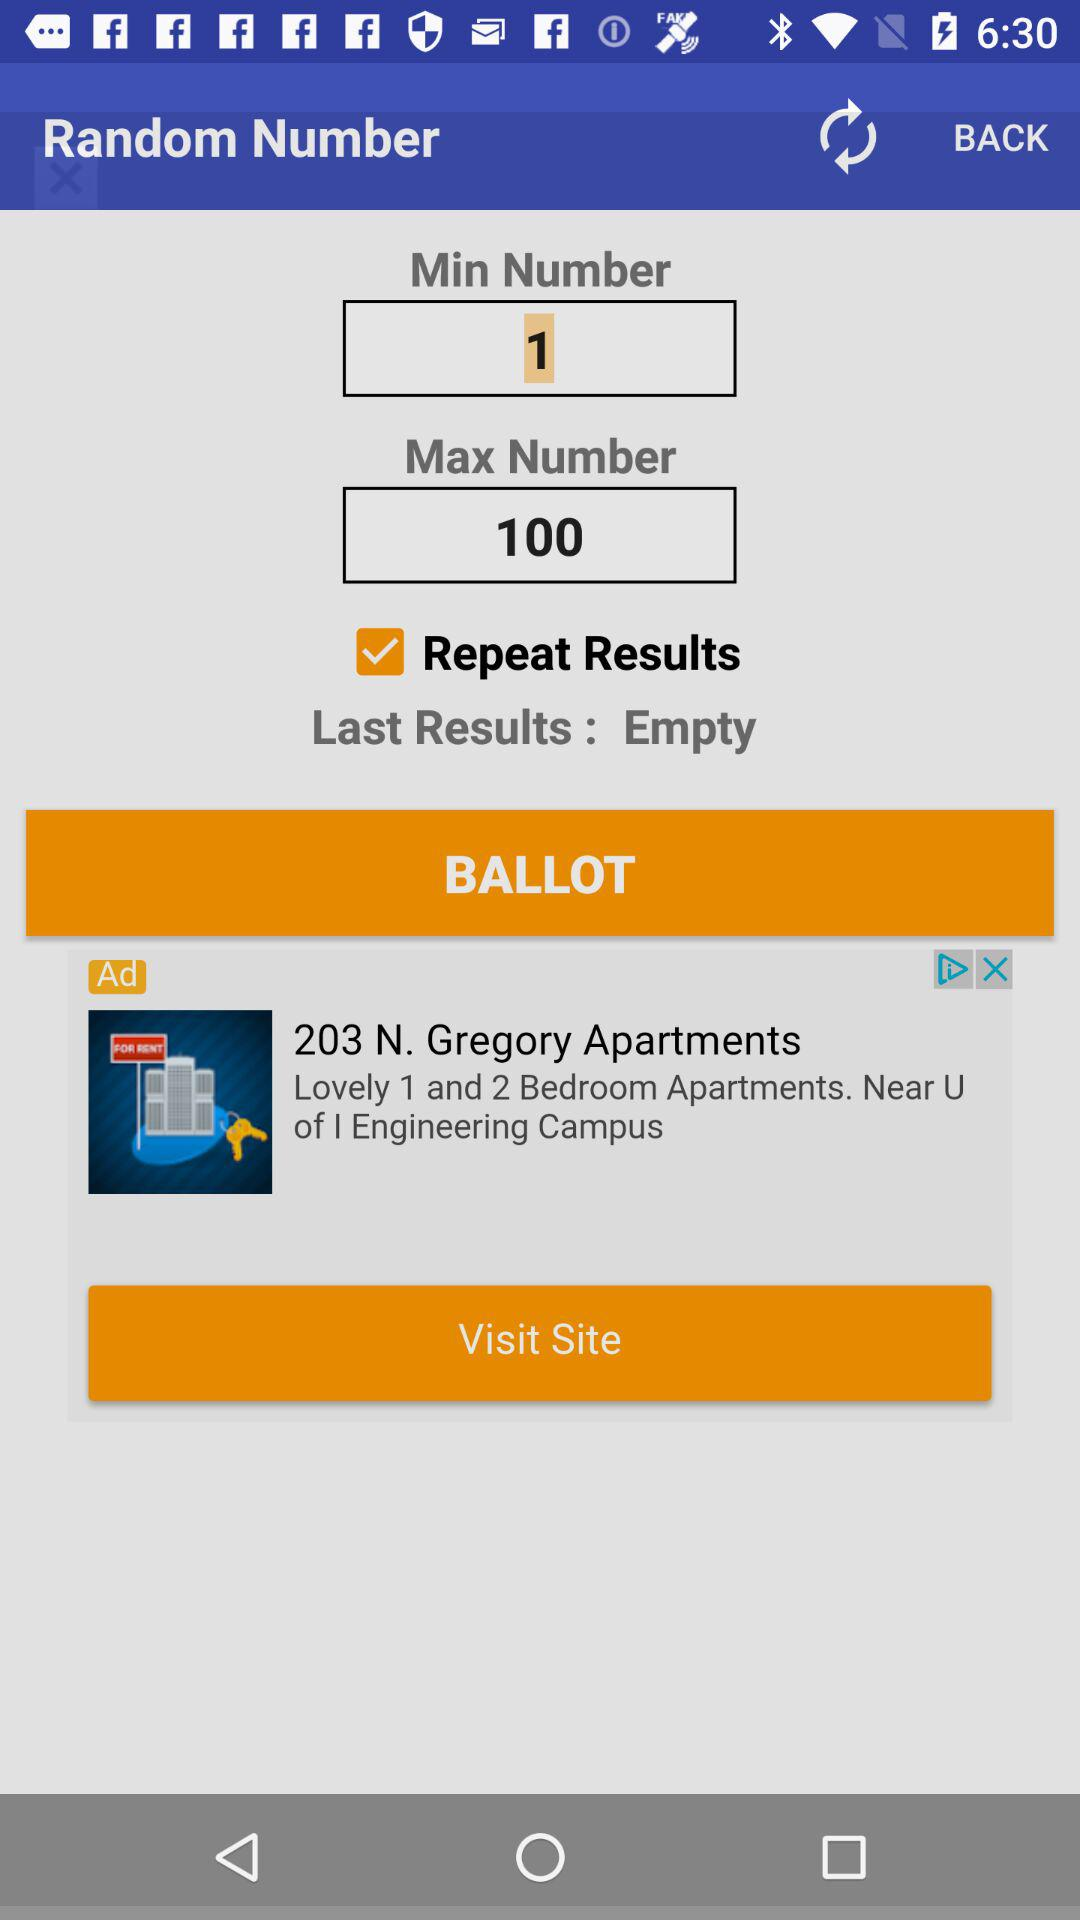What is the minimum number? The minimum number is 1. 